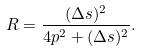Convert formula to latex. <formula><loc_0><loc_0><loc_500><loc_500>R = \frac { ( \Delta s ) ^ { 2 } } { 4 p ^ { 2 } + ( \Delta s ) ^ { 2 } } .</formula> 